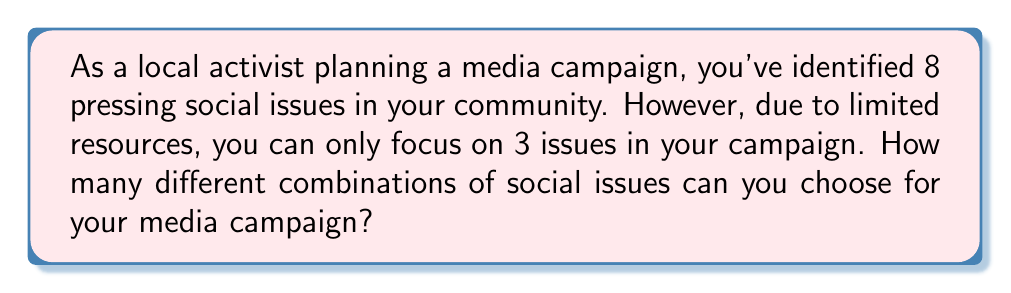Solve this math problem. This problem can be solved using the combination formula. We need to calculate the number of ways to choose 3 items from a set of 8 items, where the order doesn't matter.

The formula for combinations is:

$$C(n,r) = \frac{n!}{r!(n-r)!}$$

Where:
$n$ is the total number of items to choose from
$r$ is the number of items being chosen

In this case:
$n = 8$ (total number of social issues)
$r = 3$ (number of issues to focus on in the campaign)

Let's substitute these values into the formula:

$$C(8,3) = \frac{8!}{3!(8-3)!} = \frac{8!}{3!5!}$$

Now, let's calculate this step-by-step:

1) Expand this expression:
   $$\frac{8 * 7 * 6 * 5!}{(3 * 2 * 1) * 5!}$$

2) The 5! cancels out in the numerator and denominator:
   $$\frac{8 * 7 * 6}{3 * 2 * 1}$$

3) Multiply the numerator and denominator:
   $$\frac{336}{6}$$

4) Divide:
   $$56$$

Therefore, there are 56 different combinations of social issues that can be chosen for the media campaign.
Answer: 56 combinations 